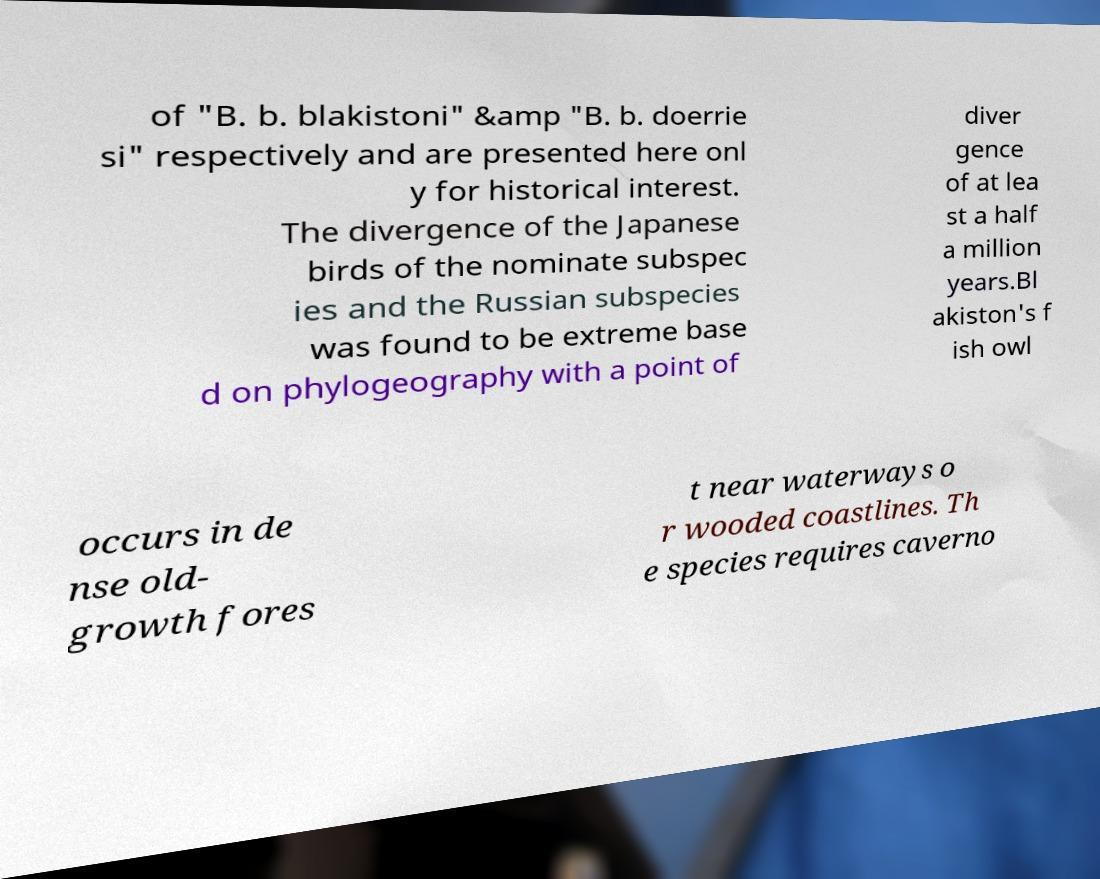Could you extract and type out the text from this image? of "B. b. blakistoni" &amp "B. b. doerrie si" respectively and are presented here onl y for historical interest. The divergence of the Japanese birds of the nominate subspec ies and the Russian subspecies was found to be extreme base d on phylogeography with a point of diver gence of at lea st a half a million years.Bl akiston's f ish owl occurs in de nse old- growth fores t near waterways o r wooded coastlines. Th e species requires caverno 